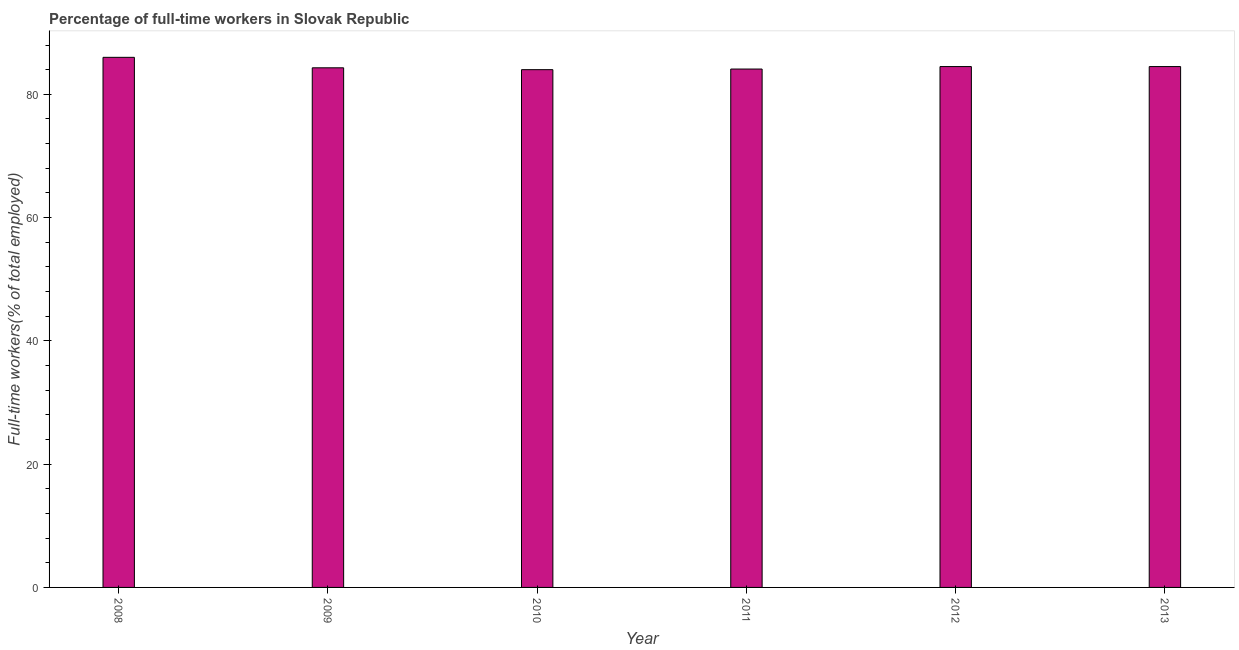Does the graph contain any zero values?
Give a very brief answer. No. What is the title of the graph?
Your response must be concise. Percentage of full-time workers in Slovak Republic. What is the label or title of the X-axis?
Give a very brief answer. Year. What is the label or title of the Y-axis?
Your answer should be very brief. Full-time workers(% of total employed). What is the percentage of full-time workers in 2013?
Ensure brevity in your answer.  84.5. Across all years, what is the minimum percentage of full-time workers?
Offer a terse response. 84. What is the sum of the percentage of full-time workers?
Make the answer very short. 507.4. What is the average percentage of full-time workers per year?
Keep it short and to the point. 84.57. What is the median percentage of full-time workers?
Your answer should be compact. 84.4. In how many years, is the percentage of full-time workers greater than 60 %?
Give a very brief answer. 6. Do a majority of the years between 2009 and 2010 (inclusive) have percentage of full-time workers greater than 40 %?
Keep it short and to the point. Yes. What is the ratio of the percentage of full-time workers in 2008 to that in 2011?
Your answer should be very brief. 1.02. What is the difference between the highest and the second highest percentage of full-time workers?
Your answer should be compact. 1.5. What is the difference between the highest and the lowest percentage of full-time workers?
Your answer should be very brief. 2. In how many years, is the percentage of full-time workers greater than the average percentage of full-time workers taken over all years?
Your answer should be very brief. 1. How many bars are there?
Your answer should be compact. 6. How many years are there in the graph?
Offer a terse response. 6. Are the values on the major ticks of Y-axis written in scientific E-notation?
Offer a very short reply. No. What is the Full-time workers(% of total employed) of 2008?
Ensure brevity in your answer.  86. What is the Full-time workers(% of total employed) of 2009?
Keep it short and to the point. 84.3. What is the Full-time workers(% of total employed) of 2010?
Make the answer very short. 84. What is the Full-time workers(% of total employed) in 2011?
Provide a short and direct response. 84.1. What is the Full-time workers(% of total employed) in 2012?
Provide a short and direct response. 84.5. What is the Full-time workers(% of total employed) of 2013?
Your response must be concise. 84.5. What is the difference between the Full-time workers(% of total employed) in 2008 and 2009?
Your response must be concise. 1.7. What is the difference between the Full-time workers(% of total employed) in 2008 and 2010?
Ensure brevity in your answer.  2. What is the difference between the Full-time workers(% of total employed) in 2008 and 2012?
Your answer should be very brief. 1.5. What is the difference between the Full-time workers(% of total employed) in 2009 and 2011?
Your response must be concise. 0.2. What is the difference between the Full-time workers(% of total employed) in 2010 and 2011?
Offer a terse response. -0.1. What is the difference between the Full-time workers(% of total employed) in 2010 and 2012?
Your response must be concise. -0.5. What is the difference between the Full-time workers(% of total employed) in 2010 and 2013?
Make the answer very short. -0.5. What is the difference between the Full-time workers(% of total employed) in 2011 and 2012?
Give a very brief answer. -0.4. What is the difference between the Full-time workers(% of total employed) in 2011 and 2013?
Ensure brevity in your answer.  -0.4. What is the difference between the Full-time workers(% of total employed) in 2012 and 2013?
Make the answer very short. 0. What is the ratio of the Full-time workers(% of total employed) in 2008 to that in 2011?
Make the answer very short. 1.02. What is the ratio of the Full-time workers(% of total employed) in 2008 to that in 2012?
Offer a terse response. 1.02. What is the ratio of the Full-time workers(% of total employed) in 2008 to that in 2013?
Keep it short and to the point. 1.02. What is the ratio of the Full-time workers(% of total employed) in 2009 to that in 2012?
Give a very brief answer. 1. What is the ratio of the Full-time workers(% of total employed) in 2009 to that in 2013?
Make the answer very short. 1. What is the ratio of the Full-time workers(% of total employed) in 2011 to that in 2012?
Make the answer very short. 0.99. What is the ratio of the Full-time workers(% of total employed) in 2011 to that in 2013?
Ensure brevity in your answer.  0.99. What is the ratio of the Full-time workers(% of total employed) in 2012 to that in 2013?
Give a very brief answer. 1. 